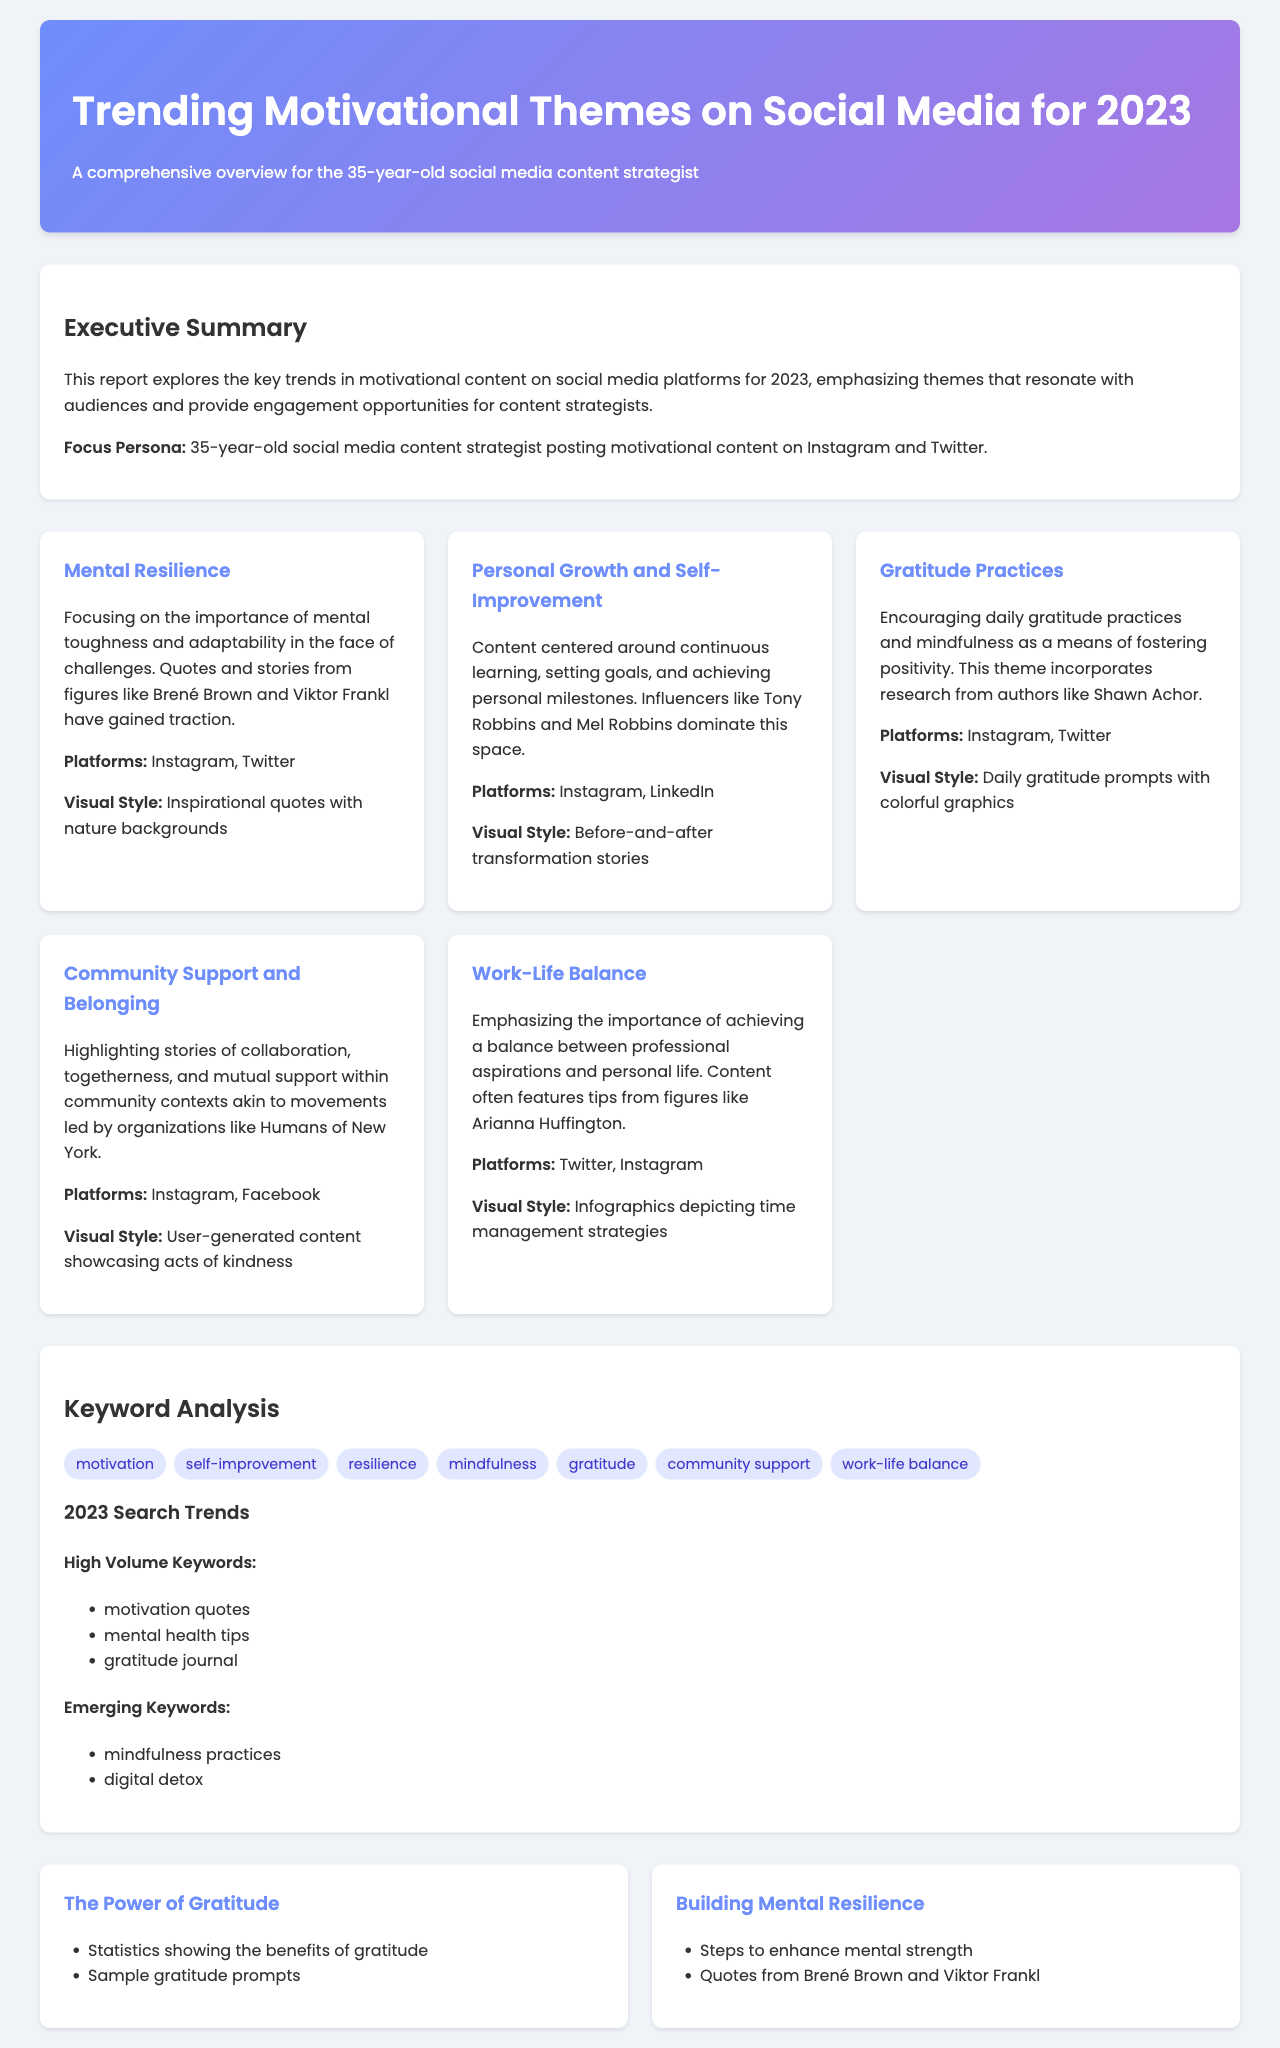What is the title of the report? The title of the report is presented in the header section of the document.
Answer: Trending Motivational Themes on Social Media for 2023 Who is the focus persona of the report? The focus persona is mentioned in the executive summary section of the document.
Answer: 35-year-old social media content strategist What is a trending theme that emphasizes adaptability? This theme is highlighted in one of the theme cards discussing the ability to handle challenges.
Answer: Mental Resilience Which influencer is mentioned in relation to personal growth? The influencer is cited in the theme card dedicated to personal growth and self-improvement.
Answer: Tony Robbins What keyword is associated with gratitude practices? The keyword is listed in the keyword analysis section pertaining to positive psychological practices.
Answer: gratitude What is one of the high volume keywords for 2023? This information is located in the keyword analysis section under 2023 search trends.
Answer: motivation quotes Which platform is noted for the theme of community support? The specific platform for this theme is specified in the corresponding theme card.
Answer: Instagram What visual style is used for work-life balance content? The document provides visual style descriptions in the theme cards.
Answer: Infographics depicting time management strategies What is one idea for an infographic mentioned in the report? Infographic ideas are detailed in a dedicated section of the document, describing content recommendations.
Answer: The Power of Gratitude 